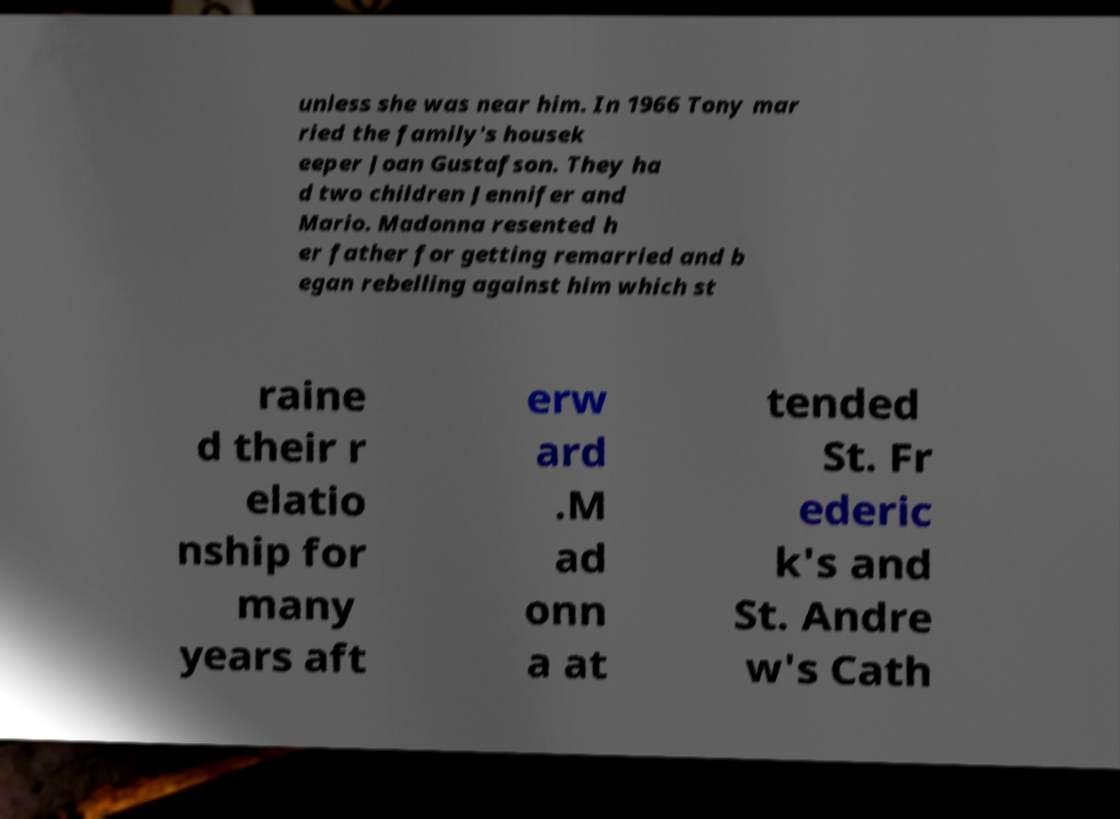Could you assist in decoding the text presented in this image and type it out clearly? unless she was near him. In 1966 Tony mar ried the family's housek eeper Joan Gustafson. They ha d two children Jennifer and Mario. Madonna resented h er father for getting remarried and b egan rebelling against him which st raine d their r elatio nship for many years aft erw ard .M ad onn a at tended St. Fr ederic k's and St. Andre w's Cath 